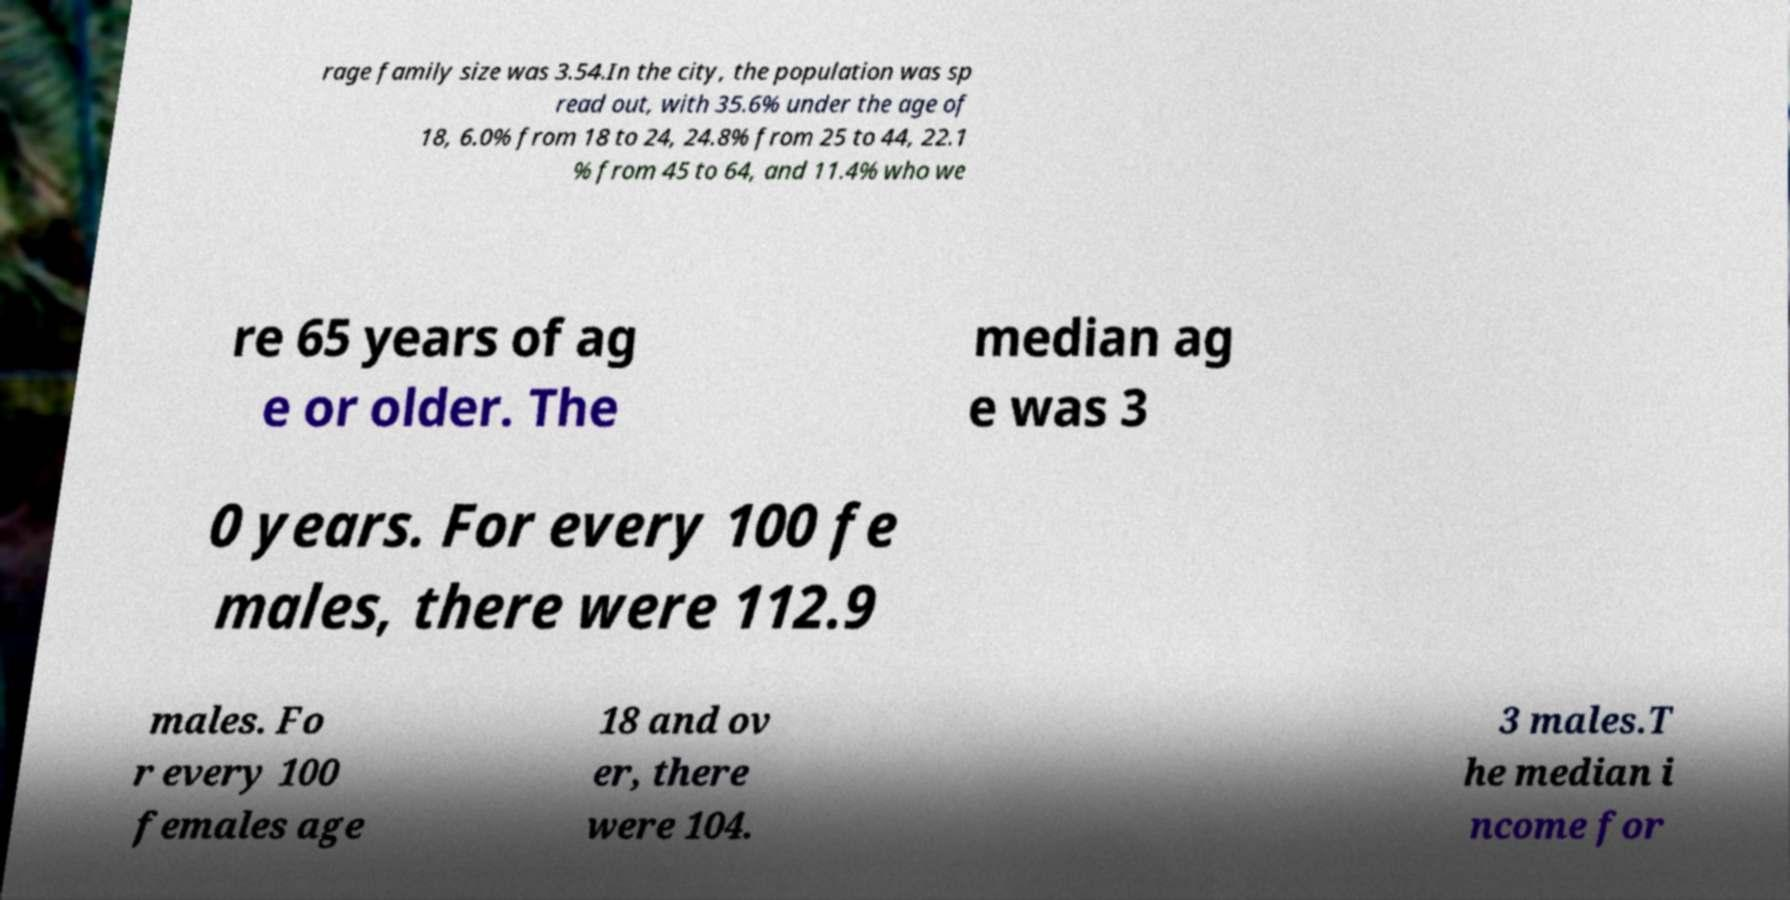Please read and relay the text visible in this image. What does it say? rage family size was 3.54.In the city, the population was sp read out, with 35.6% under the age of 18, 6.0% from 18 to 24, 24.8% from 25 to 44, 22.1 % from 45 to 64, and 11.4% who we re 65 years of ag e or older. The median ag e was 3 0 years. For every 100 fe males, there were 112.9 males. Fo r every 100 females age 18 and ov er, there were 104. 3 males.T he median i ncome for 